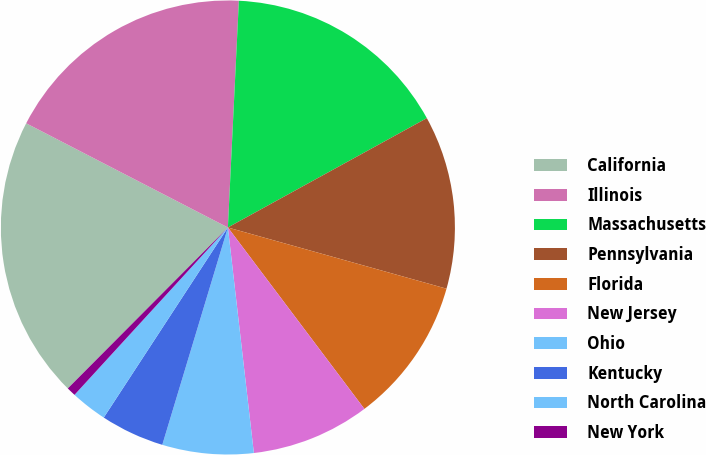<chart> <loc_0><loc_0><loc_500><loc_500><pie_chart><fcel>California<fcel>Illinois<fcel>Massachusetts<fcel>Pennsylvania<fcel>Florida<fcel>New Jersey<fcel>Ohio<fcel>Kentucky<fcel>North Carolina<fcel>New York<nl><fcel>20.13%<fcel>18.18%<fcel>16.23%<fcel>12.34%<fcel>10.39%<fcel>8.44%<fcel>6.49%<fcel>4.54%<fcel>2.6%<fcel>0.65%<nl></chart> 